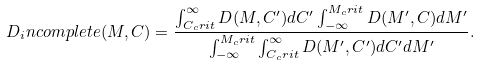<formula> <loc_0><loc_0><loc_500><loc_500>D _ { i } n c o m p l e t e ( M , C ) = \frac { \int _ { C _ { c } r i t } ^ { \infty } D ( M , C ^ { \prime } ) d C ^ { \prime } \int _ { - \infty } ^ { M _ { c } r i t } D ( M ^ { \prime } , C ) d M ^ { \prime } } { \int _ { - \infty } ^ { M _ { c } r i t } \int _ { C _ { c } r i t } ^ { \infty } D ( M ^ { \prime } , C ^ { \prime } ) d C ^ { \prime } d M ^ { \prime } } .</formula> 